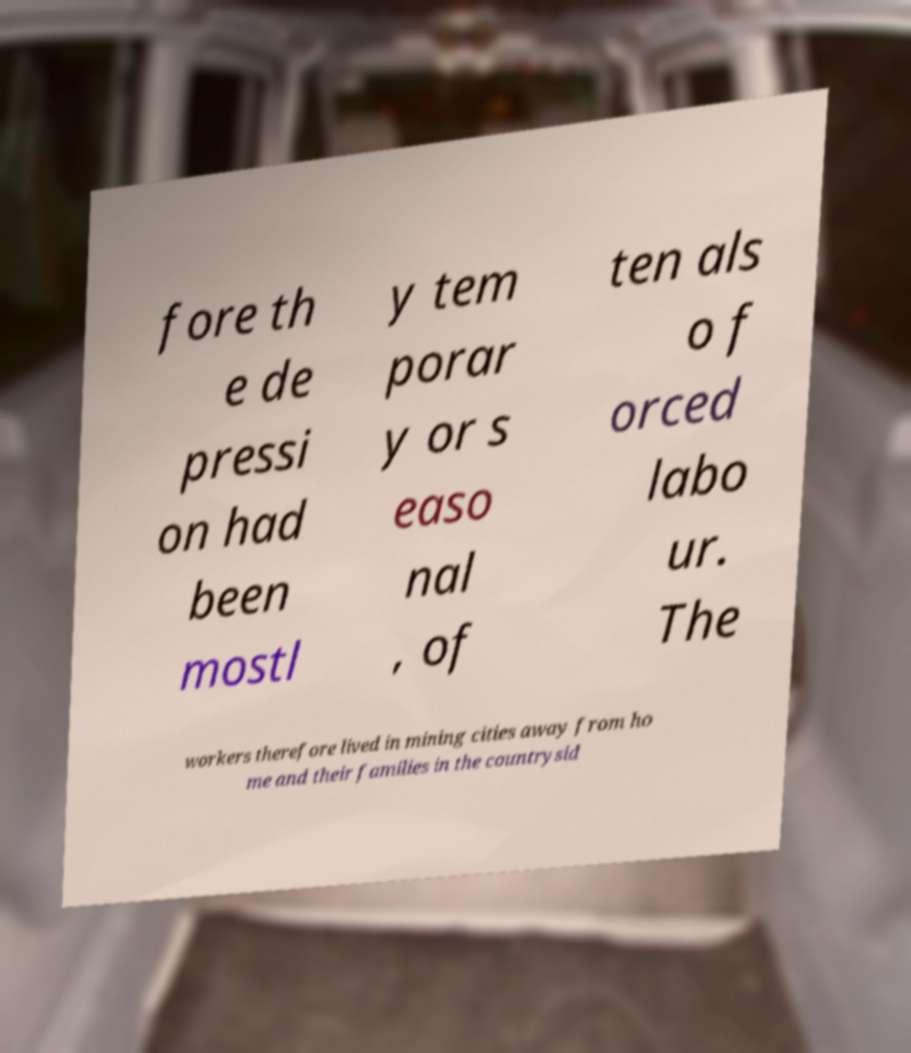Could you extract and type out the text from this image? fore th e de pressi on had been mostl y tem porar y or s easo nal , of ten als o f orced labo ur. The workers therefore lived in mining cities away from ho me and their families in the countrysid 